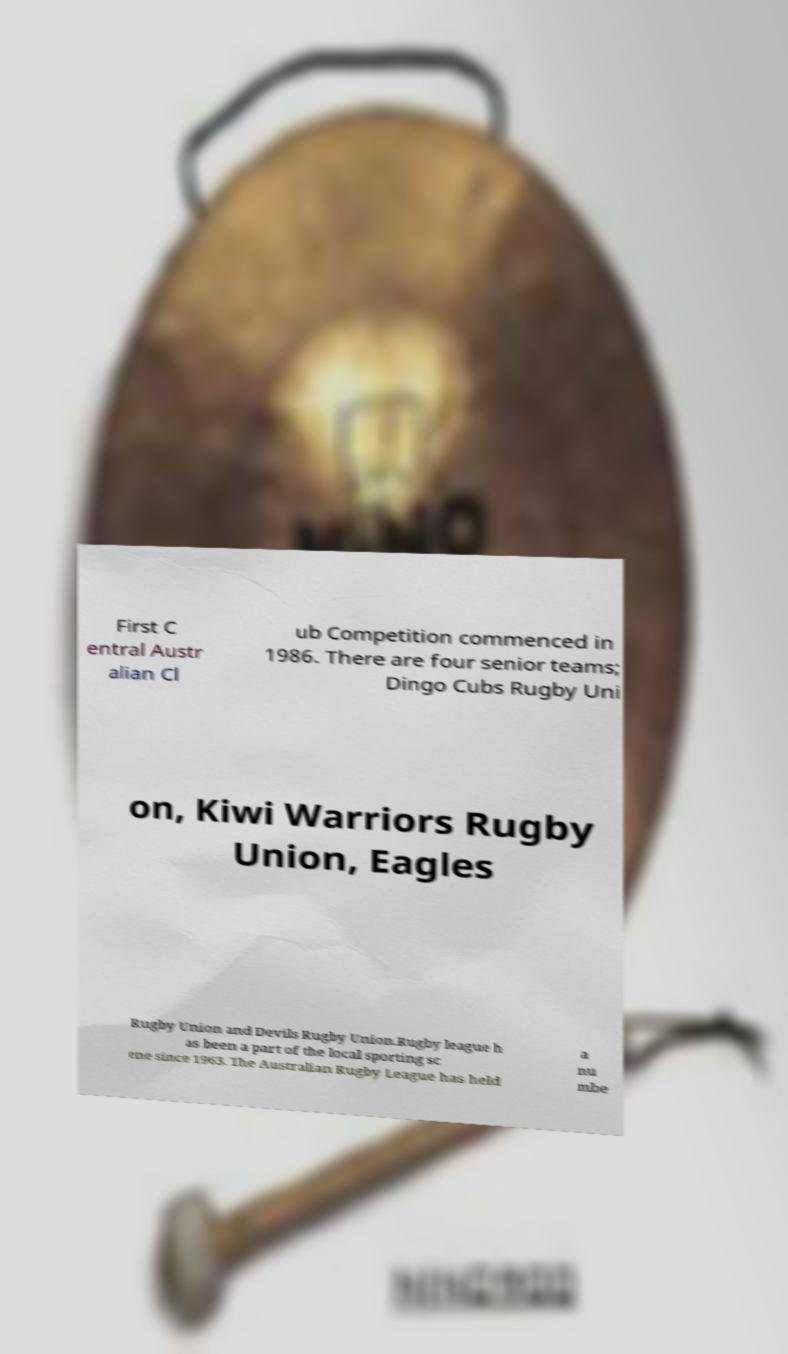Could you extract and type out the text from this image? First C entral Austr alian Cl ub Competition commenced in 1986. There are four senior teams; Dingo Cubs Rugby Uni on, Kiwi Warriors Rugby Union, Eagles Rugby Union and Devils Rugby Union.Rugby league h as been a part of the local sporting sc ene since 1963. The Australian Rugby League has held a nu mbe 